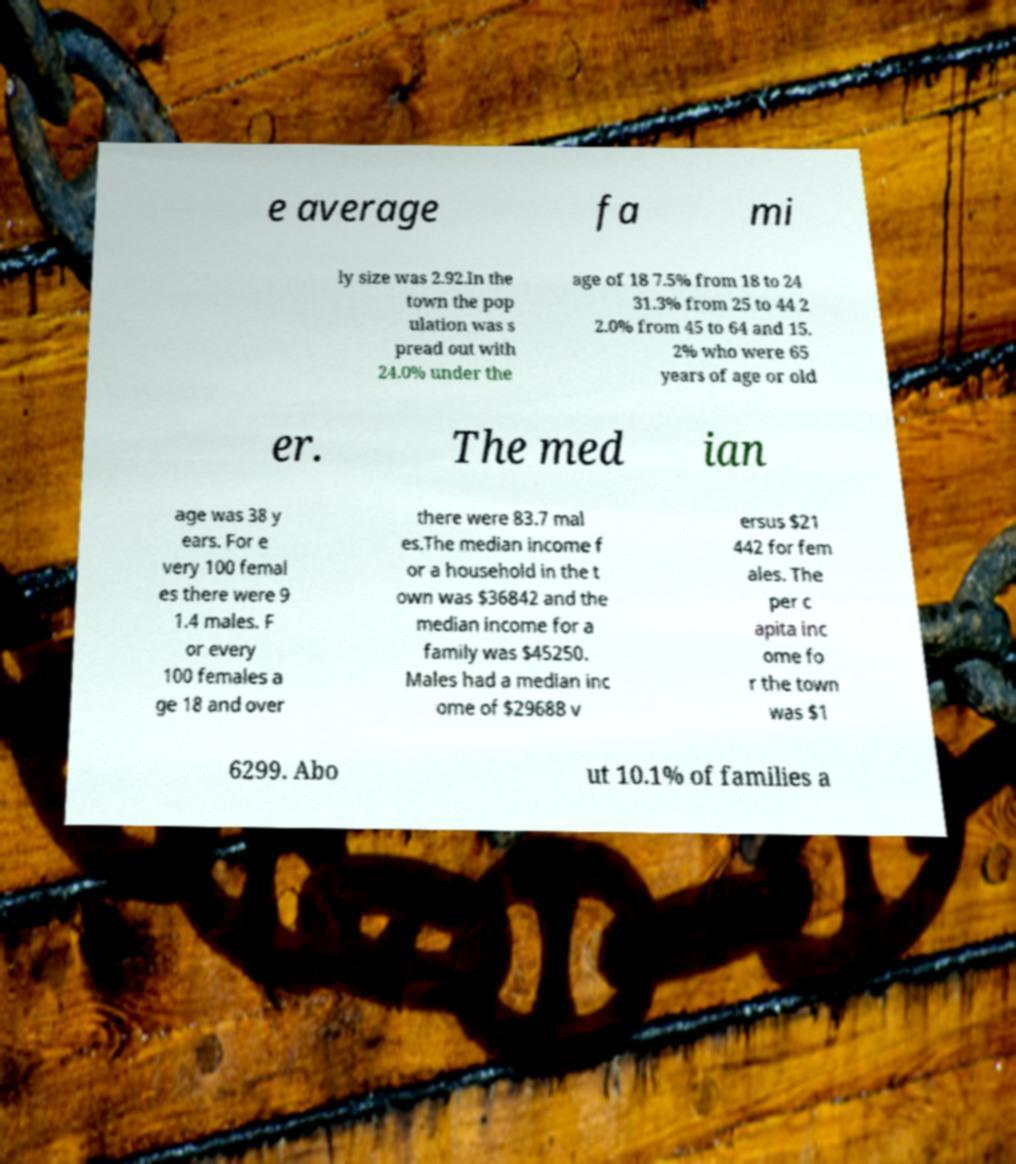I need the written content from this picture converted into text. Can you do that? e average fa mi ly size was 2.92.In the town the pop ulation was s pread out with 24.0% under the age of 18 7.5% from 18 to 24 31.3% from 25 to 44 2 2.0% from 45 to 64 and 15. 2% who were 65 years of age or old er. The med ian age was 38 y ears. For e very 100 femal es there were 9 1.4 males. F or every 100 females a ge 18 and over there were 83.7 mal es.The median income f or a household in the t own was $36842 and the median income for a family was $45250. Males had a median inc ome of $29688 v ersus $21 442 for fem ales. The per c apita inc ome fo r the town was $1 6299. Abo ut 10.1% of families a 